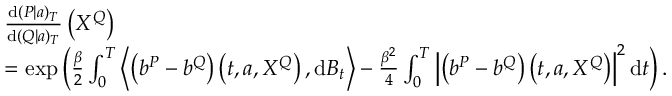<formula> <loc_0><loc_0><loc_500><loc_500>\begin{array} { r l } & { \frac { d ( P | a ) _ { T } } { d ( Q | a ) _ { T } } \left ( X ^ { Q } \right ) } \\ & { = \exp \left ( \frac { \beta } { 2 } \int _ { 0 } ^ { T } \left \langle \left ( b ^ { P } - b ^ { Q } \right ) \left ( t , a , X ^ { Q } \right ) , d B _ { t } \right \rangle - \frac { \beta ^ { 2 } } { 4 } \int _ { 0 } ^ { T } \left | \left ( b ^ { P } - b ^ { Q } \right ) \left ( t , a , X ^ { Q } \right ) \right | ^ { 2 } d t \right ) . } \end{array}</formula> 